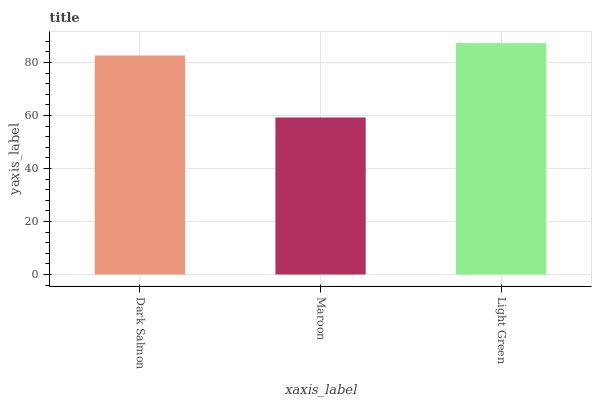Is Maroon the minimum?
Answer yes or no. Yes. Is Light Green the maximum?
Answer yes or no. Yes. Is Light Green the minimum?
Answer yes or no. No. Is Maroon the maximum?
Answer yes or no. No. Is Light Green greater than Maroon?
Answer yes or no. Yes. Is Maroon less than Light Green?
Answer yes or no. Yes. Is Maroon greater than Light Green?
Answer yes or no. No. Is Light Green less than Maroon?
Answer yes or no. No. Is Dark Salmon the high median?
Answer yes or no. Yes. Is Dark Salmon the low median?
Answer yes or no. Yes. Is Light Green the high median?
Answer yes or no. No. Is Light Green the low median?
Answer yes or no. No. 